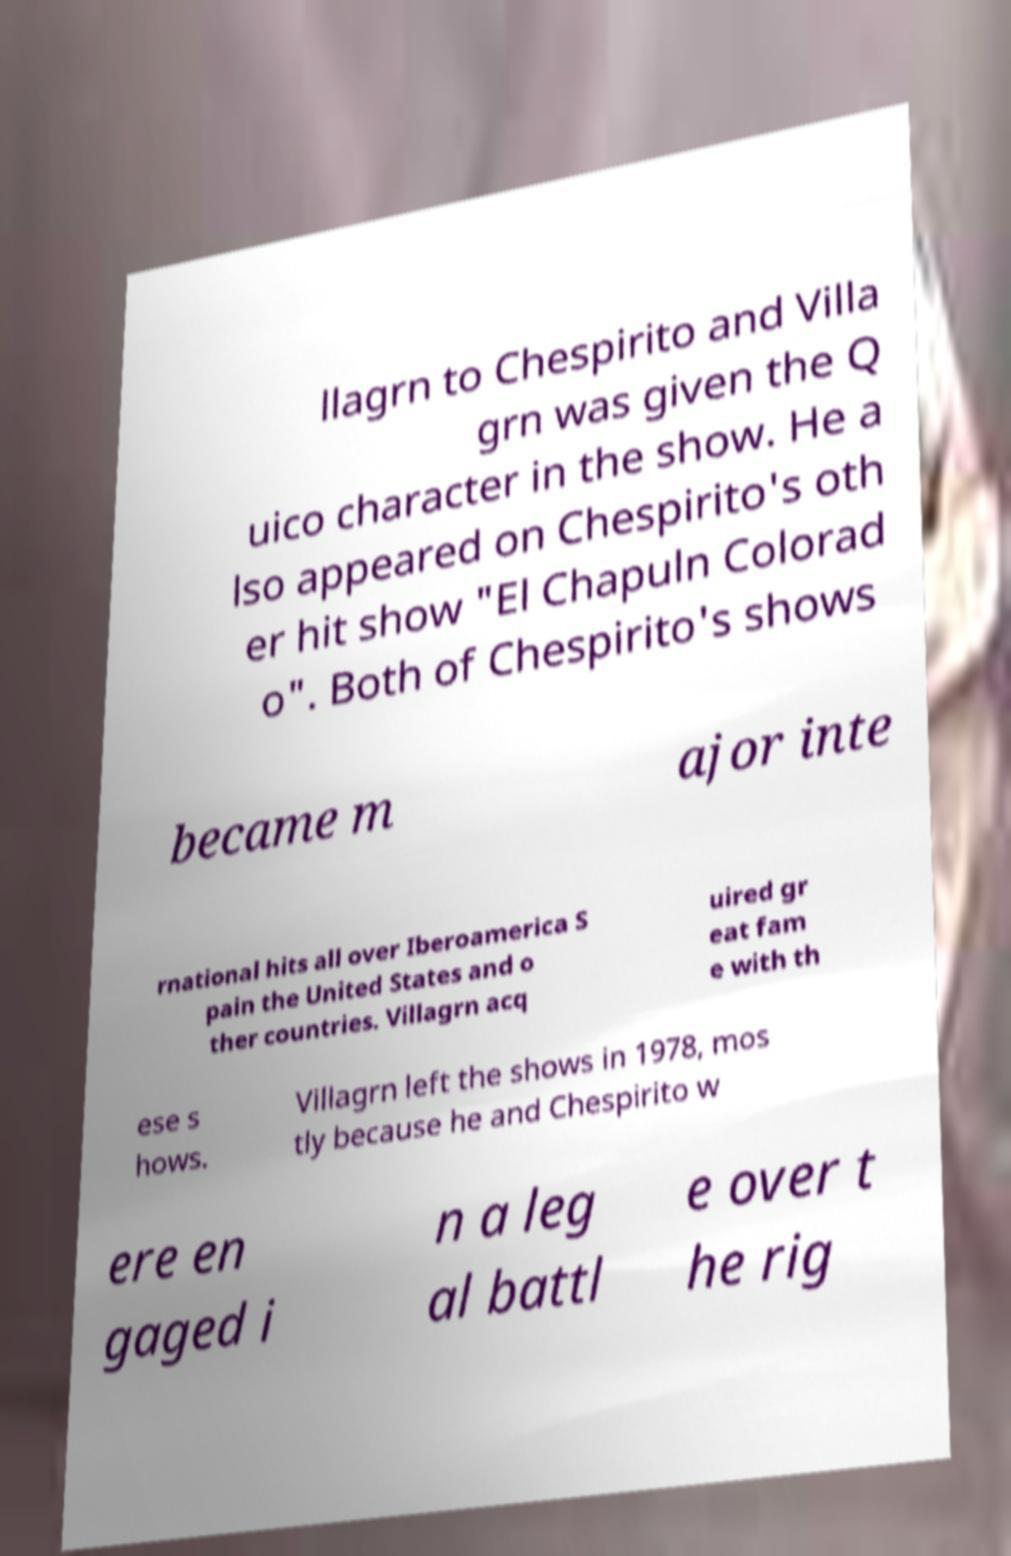Please identify and transcribe the text found in this image. llagrn to Chespirito and Villa grn was given the Q uico character in the show. He a lso appeared on Chespirito's oth er hit show "El Chapuln Colorad o". Both of Chespirito's shows became m ajor inte rnational hits all over Iberoamerica S pain the United States and o ther countries. Villagrn acq uired gr eat fam e with th ese s hows. Villagrn left the shows in 1978, mos tly because he and Chespirito w ere en gaged i n a leg al battl e over t he rig 